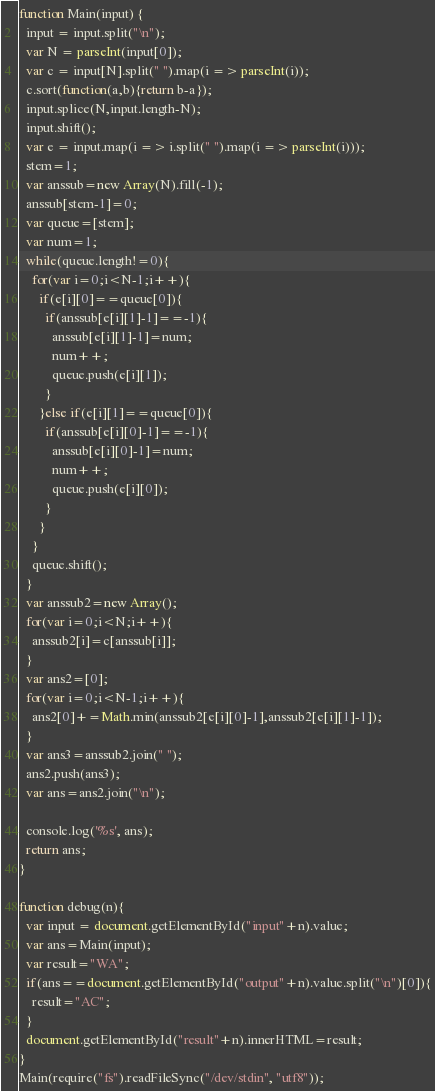<code> <loc_0><loc_0><loc_500><loc_500><_JavaScript_>

function Main(input) {
  input = input.split("\n");
  var N = parseInt(input[0]);
  var c = input[N].split(" ").map(i => parseInt(i));
  c.sort(function(a,b){return b-a});
  input.splice(N,input.length-N);
  input.shift();
  var e = input.map(i => i.split(" ").map(i => parseInt(i)));
  stem=1;
  var anssub=new Array(N).fill(-1);
  anssub[stem-1]=0;
  var queue=[stem];
  var num=1;
  while(queue.length!=0){
    for(var i=0;i<N-1;i++){
      if(e[i][0]==queue[0]){
        if(anssub[e[i][1]-1]==-1){
          anssub[e[i][1]-1]=num;
          num++;
          queue.push(e[i][1]);
        }
      }else if(e[i][1]==queue[0]){
        if(anssub[e[i][0]-1]==-1){
          anssub[e[i][0]-1]=num;
          num++;
          queue.push(e[i][0]);
        }
      }
    }
    queue.shift();
  }
  var anssub2=new Array();
  for(var i=0;i<N;i++){
    anssub2[i]=c[anssub[i]];
  }
  var ans2=[0];
  for(var i=0;i<N-1;i++){
    ans2[0]+=Math.min(anssub2[e[i][0]-1],anssub2[e[i][1]-1]);
  }
  var ans3=anssub2.join(" ");
  ans2.push(ans3);
  var ans=ans2.join("\n");

  console.log('%s', ans);
  return ans;
}

function debug(n){
  var input = document.getElementById("input"+n).value;
  var ans=Main(input);
  var result="WA";
  if(ans==document.getElementById("output"+n).value.split("\n")[0]){
    result="AC";
  }
  document.getElementById("result"+n).innerHTML=result;
}
Main(require("fs").readFileSync("/dev/stdin", "utf8"));</code> 